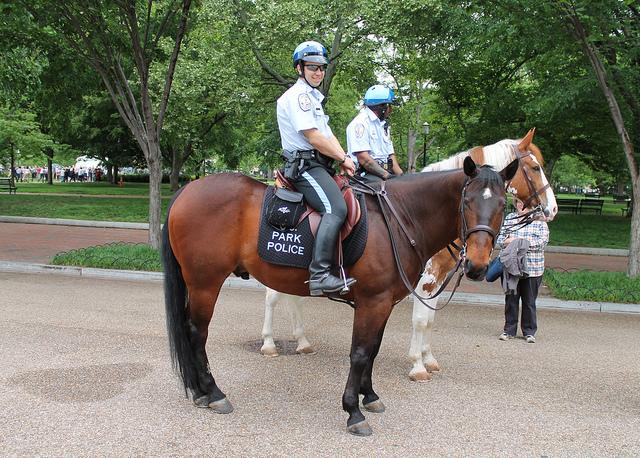Is there seemingly enough space for the horse to run?
Give a very brief answer. Yes. What color is the horse's blanket?
Answer briefly. Black. What are the riders known as?
Answer briefly. Police. What color helmets are the mounted police wearing?
Be succinct. Blue. What does the saddle pad say?
Write a very short answer. Park police. What color are there helmets?
Be succinct. Blue. What color is the hat the person is wearing?
Write a very short answer. Blue. Is the horse in motion?
Be succinct. No. What is the man on the right riding?
Concise answer only. Horse. Is there one or two horses?
Write a very short answer. 2. Are the riders large?
Short answer required. No. What are these professionals?
Give a very brief answer. Police. Is the man happy?
Quick response, please. Yes. 